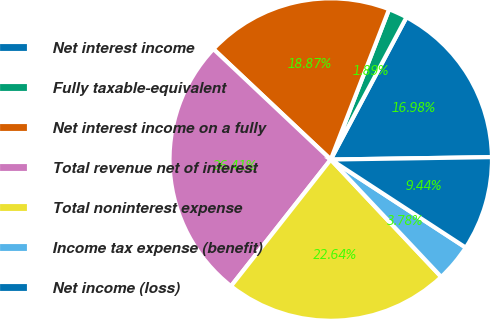<chart> <loc_0><loc_0><loc_500><loc_500><pie_chart><fcel>Net interest income<fcel>Fully taxable-equivalent<fcel>Net interest income on a fully<fcel>Total revenue net of interest<fcel>Total noninterest expense<fcel>Income tax expense (benefit)<fcel>Net income (loss)<nl><fcel>16.98%<fcel>1.89%<fcel>18.87%<fcel>26.41%<fcel>22.64%<fcel>3.78%<fcel>9.44%<nl></chart> 